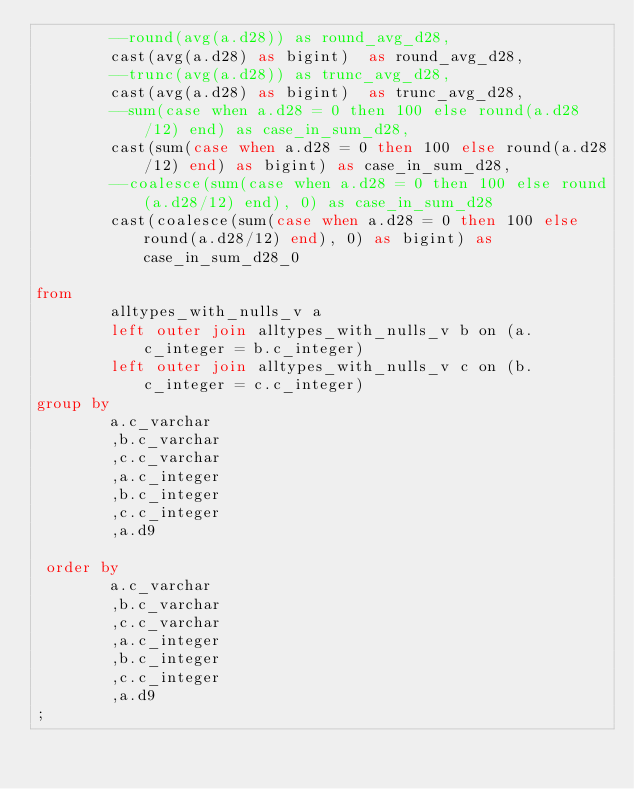Convert code to text. <code><loc_0><loc_0><loc_500><loc_500><_SQL_> 		--round(avg(a.d28))	as round_avg_d28,
 		cast(avg(a.d28) as bigint)	as round_avg_d28,
 		--trunc(avg(a.d28))	as trunc_avg_d28,
 		cast(avg(a.d28) as bigint)	as trunc_avg_d28,
 		--sum(case when a.d28 = 0 then 100 else round(a.d28/12) end) as case_in_sum_d28,
 		cast(sum(case when a.d28 = 0 then 100 else round(a.d28/12) end) as bigint) as case_in_sum_d28,
 		--coalesce(sum(case when a.d28 = 0 then 100 else round(a.d28/12) end), 0) as case_in_sum_d28
 		cast(coalesce(sum(case when a.d28 = 0 then 100 else round(a.d28/12) end), 0) as bigint) as case_in_sum_d28_0
 
from
 		alltypes_with_nulls_v a
		left outer join alltypes_with_nulls_v b on (a.c_integer = b.c_integer)
		left outer join alltypes_with_nulls_v c on (b.c_integer = c.c_integer)
group by
  		a.c_varchar
 		,b.c_varchar
 		,c.c_varchar
 		,a.c_integer
 		,b.c_integer
 		,c.c_integer
 		,a.d9

 order by
  		a.c_varchar
 		,b.c_varchar
 		,c.c_varchar
 		,a.c_integer
 		,b.c_integer
 		,c.c_integer
 		,a.d9
;
</code> 